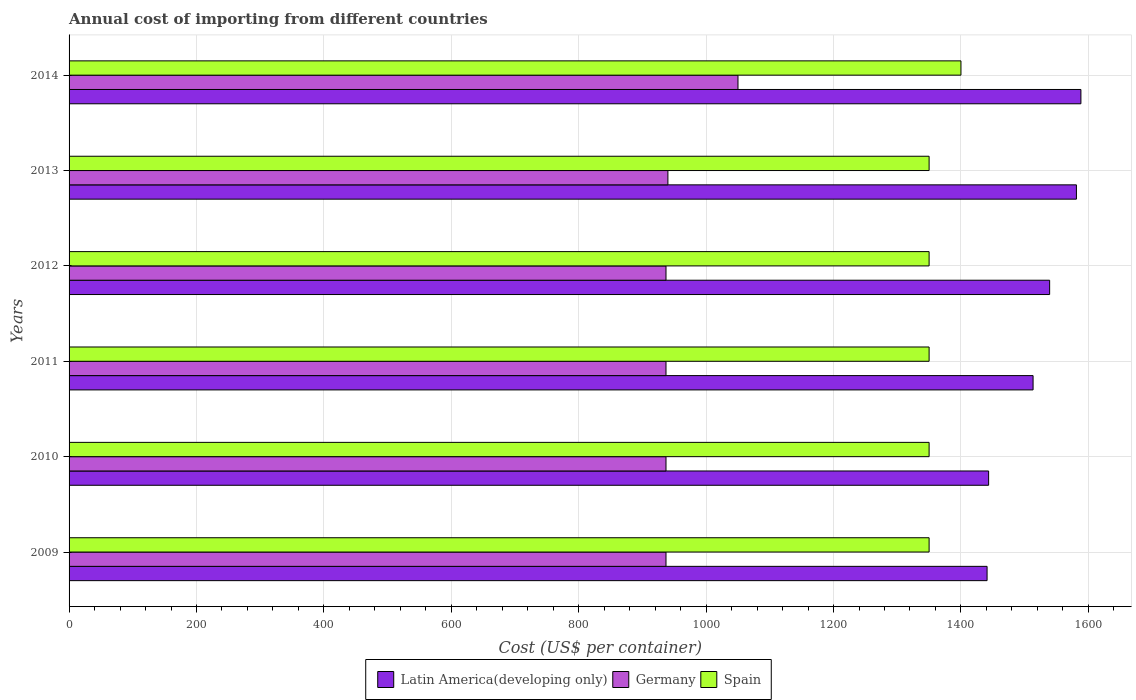Are the number of bars per tick equal to the number of legend labels?
Ensure brevity in your answer.  Yes. How many bars are there on the 5th tick from the top?
Offer a terse response. 3. How many bars are there on the 4th tick from the bottom?
Offer a terse response. 3. In how many cases, is the number of bars for a given year not equal to the number of legend labels?
Provide a short and direct response. 0. What is the total annual cost of importing in Spain in 2014?
Your response must be concise. 1400. Across all years, what is the maximum total annual cost of importing in Germany?
Offer a very short reply. 1050. Across all years, what is the minimum total annual cost of importing in Latin America(developing only)?
Provide a short and direct response. 1441. In which year was the total annual cost of importing in Spain maximum?
Provide a short and direct response. 2014. What is the total total annual cost of importing in Germany in the graph?
Make the answer very short. 5738. What is the difference between the total annual cost of importing in Germany in 2011 and that in 2012?
Provide a short and direct response. 0. What is the difference between the total annual cost of importing in Spain in 2011 and the total annual cost of importing in Latin America(developing only) in 2013?
Offer a terse response. -231.26. What is the average total annual cost of importing in Germany per year?
Give a very brief answer. 956.33. In the year 2012, what is the difference between the total annual cost of importing in Germany and total annual cost of importing in Latin America(developing only)?
Provide a short and direct response. -602.22. In how many years, is the total annual cost of importing in Germany greater than 880 US$?
Make the answer very short. 6. Is the difference between the total annual cost of importing in Germany in 2009 and 2013 greater than the difference between the total annual cost of importing in Latin America(developing only) in 2009 and 2013?
Offer a very short reply. Yes. What is the difference between the highest and the second highest total annual cost of importing in Latin America(developing only)?
Make the answer very short. 7.02. What is the difference between the highest and the lowest total annual cost of importing in Germany?
Provide a short and direct response. 113. Is the sum of the total annual cost of importing in Spain in 2011 and 2013 greater than the maximum total annual cost of importing in Latin America(developing only) across all years?
Give a very brief answer. Yes. What does the 1st bar from the top in 2010 represents?
Provide a succinct answer. Spain. What does the 1st bar from the bottom in 2011 represents?
Offer a very short reply. Latin America(developing only). Is it the case that in every year, the sum of the total annual cost of importing in Spain and total annual cost of importing in Germany is greater than the total annual cost of importing in Latin America(developing only)?
Your answer should be compact. Yes. How many bars are there?
Offer a terse response. 18. How many years are there in the graph?
Keep it short and to the point. 6. How many legend labels are there?
Offer a terse response. 3. How are the legend labels stacked?
Give a very brief answer. Horizontal. What is the title of the graph?
Provide a succinct answer. Annual cost of importing from different countries. What is the label or title of the X-axis?
Your answer should be compact. Cost (US$ per container). What is the label or title of the Y-axis?
Ensure brevity in your answer.  Years. What is the Cost (US$ per container) of Latin America(developing only) in 2009?
Your answer should be compact. 1441. What is the Cost (US$ per container) of Germany in 2009?
Ensure brevity in your answer.  937. What is the Cost (US$ per container) of Spain in 2009?
Offer a very short reply. 1350. What is the Cost (US$ per container) of Latin America(developing only) in 2010?
Offer a terse response. 1443.43. What is the Cost (US$ per container) of Germany in 2010?
Offer a very short reply. 937. What is the Cost (US$ per container) in Spain in 2010?
Ensure brevity in your answer.  1350. What is the Cost (US$ per container) of Latin America(developing only) in 2011?
Give a very brief answer. 1513.22. What is the Cost (US$ per container) of Germany in 2011?
Offer a very short reply. 937. What is the Cost (US$ per container) in Spain in 2011?
Give a very brief answer. 1350. What is the Cost (US$ per container) in Latin America(developing only) in 2012?
Your answer should be compact. 1539.22. What is the Cost (US$ per container) of Germany in 2012?
Your response must be concise. 937. What is the Cost (US$ per container) in Spain in 2012?
Keep it short and to the point. 1350. What is the Cost (US$ per container) in Latin America(developing only) in 2013?
Provide a short and direct response. 1581.26. What is the Cost (US$ per container) of Germany in 2013?
Give a very brief answer. 940. What is the Cost (US$ per container) of Spain in 2013?
Your response must be concise. 1350. What is the Cost (US$ per container) of Latin America(developing only) in 2014?
Your response must be concise. 1588.28. What is the Cost (US$ per container) of Germany in 2014?
Make the answer very short. 1050. What is the Cost (US$ per container) of Spain in 2014?
Your answer should be very brief. 1400. Across all years, what is the maximum Cost (US$ per container) of Latin America(developing only)?
Keep it short and to the point. 1588.28. Across all years, what is the maximum Cost (US$ per container) of Germany?
Provide a succinct answer. 1050. Across all years, what is the maximum Cost (US$ per container) of Spain?
Offer a very short reply. 1400. Across all years, what is the minimum Cost (US$ per container) of Latin America(developing only)?
Your answer should be compact. 1441. Across all years, what is the minimum Cost (US$ per container) of Germany?
Give a very brief answer. 937. Across all years, what is the minimum Cost (US$ per container) of Spain?
Give a very brief answer. 1350. What is the total Cost (US$ per container) in Latin America(developing only) in the graph?
Offer a terse response. 9106.4. What is the total Cost (US$ per container) in Germany in the graph?
Your answer should be compact. 5738. What is the total Cost (US$ per container) in Spain in the graph?
Ensure brevity in your answer.  8150. What is the difference between the Cost (US$ per container) of Latin America(developing only) in 2009 and that in 2010?
Your answer should be compact. -2.43. What is the difference between the Cost (US$ per container) of Latin America(developing only) in 2009 and that in 2011?
Provide a succinct answer. -72.22. What is the difference between the Cost (US$ per container) of Spain in 2009 and that in 2011?
Your response must be concise. 0. What is the difference between the Cost (US$ per container) in Latin America(developing only) in 2009 and that in 2012?
Provide a succinct answer. -98.22. What is the difference between the Cost (US$ per container) of Germany in 2009 and that in 2012?
Offer a terse response. 0. What is the difference between the Cost (US$ per container) of Latin America(developing only) in 2009 and that in 2013?
Make the answer very short. -140.26. What is the difference between the Cost (US$ per container) in Germany in 2009 and that in 2013?
Provide a succinct answer. -3. What is the difference between the Cost (US$ per container) of Spain in 2009 and that in 2013?
Your answer should be very brief. 0. What is the difference between the Cost (US$ per container) in Latin America(developing only) in 2009 and that in 2014?
Make the answer very short. -147.28. What is the difference between the Cost (US$ per container) of Germany in 2009 and that in 2014?
Your response must be concise. -113. What is the difference between the Cost (US$ per container) in Spain in 2009 and that in 2014?
Offer a terse response. -50. What is the difference between the Cost (US$ per container) of Latin America(developing only) in 2010 and that in 2011?
Your answer should be very brief. -69.78. What is the difference between the Cost (US$ per container) in Germany in 2010 and that in 2011?
Your answer should be compact. 0. What is the difference between the Cost (US$ per container) of Spain in 2010 and that in 2011?
Provide a short and direct response. 0. What is the difference between the Cost (US$ per container) of Latin America(developing only) in 2010 and that in 2012?
Provide a succinct answer. -95.78. What is the difference between the Cost (US$ per container) of Germany in 2010 and that in 2012?
Provide a short and direct response. 0. What is the difference between the Cost (US$ per container) of Spain in 2010 and that in 2012?
Offer a very short reply. 0. What is the difference between the Cost (US$ per container) in Latin America(developing only) in 2010 and that in 2013?
Provide a succinct answer. -137.82. What is the difference between the Cost (US$ per container) of Latin America(developing only) in 2010 and that in 2014?
Keep it short and to the point. -144.84. What is the difference between the Cost (US$ per container) in Germany in 2010 and that in 2014?
Make the answer very short. -113. What is the difference between the Cost (US$ per container) of Germany in 2011 and that in 2012?
Give a very brief answer. 0. What is the difference between the Cost (US$ per container) in Spain in 2011 and that in 2012?
Provide a short and direct response. 0. What is the difference between the Cost (US$ per container) of Latin America(developing only) in 2011 and that in 2013?
Ensure brevity in your answer.  -68.04. What is the difference between the Cost (US$ per container) in Spain in 2011 and that in 2013?
Provide a short and direct response. 0. What is the difference between the Cost (US$ per container) in Latin America(developing only) in 2011 and that in 2014?
Provide a succinct answer. -75.06. What is the difference between the Cost (US$ per container) of Germany in 2011 and that in 2014?
Your answer should be compact. -113. What is the difference between the Cost (US$ per container) of Spain in 2011 and that in 2014?
Give a very brief answer. -50. What is the difference between the Cost (US$ per container) of Latin America(developing only) in 2012 and that in 2013?
Ensure brevity in your answer.  -42.04. What is the difference between the Cost (US$ per container) in Germany in 2012 and that in 2013?
Provide a succinct answer. -3. What is the difference between the Cost (US$ per container) of Latin America(developing only) in 2012 and that in 2014?
Provide a succinct answer. -49.06. What is the difference between the Cost (US$ per container) in Germany in 2012 and that in 2014?
Keep it short and to the point. -113. What is the difference between the Cost (US$ per container) of Latin America(developing only) in 2013 and that in 2014?
Make the answer very short. -7.02. What is the difference between the Cost (US$ per container) in Germany in 2013 and that in 2014?
Offer a very short reply. -110. What is the difference between the Cost (US$ per container) in Spain in 2013 and that in 2014?
Offer a terse response. -50. What is the difference between the Cost (US$ per container) of Latin America(developing only) in 2009 and the Cost (US$ per container) of Germany in 2010?
Your response must be concise. 504. What is the difference between the Cost (US$ per container) of Latin America(developing only) in 2009 and the Cost (US$ per container) of Spain in 2010?
Your response must be concise. 91. What is the difference between the Cost (US$ per container) of Germany in 2009 and the Cost (US$ per container) of Spain in 2010?
Give a very brief answer. -413. What is the difference between the Cost (US$ per container) of Latin America(developing only) in 2009 and the Cost (US$ per container) of Germany in 2011?
Your answer should be very brief. 504. What is the difference between the Cost (US$ per container) of Latin America(developing only) in 2009 and the Cost (US$ per container) of Spain in 2011?
Your answer should be compact. 91. What is the difference between the Cost (US$ per container) of Germany in 2009 and the Cost (US$ per container) of Spain in 2011?
Your response must be concise. -413. What is the difference between the Cost (US$ per container) in Latin America(developing only) in 2009 and the Cost (US$ per container) in Germany in 2012?
Offer a terse response. 504. What is the difference between the Cost (US$ per container) in Latin America(developing only) in 2009 and the Cost (US$ per container) in Spain in 2012?
Offer a terse response. 91. What is the difference between the Cost (US$ per container) in Germany in 2009 and the Cost (US$ per container) in Spain in 2012?
Your answer should be very brief. -413. What is the difference between the Cost (US$ per container) in Latin America(developing only) in 2009 and the Cost (US$ per container) in Germany in 2013?
Your answer should be very brief. 501. What is the difference between the Cost (US$ per container) of Latin America(developing only) in 2009 and the Cost (US$ per container) of Spain in 2013?
Provide a short and direct response. 91. What is the difference between the Cost (US$ per container) of Germany in 2009 and the Cost (US$ per container) of Spain in 2013?
Ensure brevity in your answer.  -413. What is the difference between the Cost (US$ per container) of Latin America(developing only) in 2009 and the Cost (US$ per container) of Germany in 2014?
Provide a short and direct response. 391. What is the difference between the Cost (US$ per container) of Latin America(developing only) in 2009 and the Cost (US$ per container) of Spain in 2014?
Give a very brief answer. 41. What is the difference between the Cost (US$ per container) in Germany in 2009 and the Cost (US$ per container) in Spain in 2014?
Provide a short and direct response. -463. What is the difference between the Cost (US$ per container) in Latin America(developing only) in 2010 and the Cost (US$ per container) in Germany in 2011?
Offer a very short reply. 506.43. What is the difference between the Cost (US$ per container) of Latin America(developing only) in 2010 and the Cost (US$ per container) of Spain in 2011?
Your response must be concise. 93.43. What is the difference between the Cost (US$ per container) in Germany in 2010 and the Cost (US$ per container) in Spain in 2011?
Offer a very short reply. -413. What is the difference between the Cost (US$ per container) of Latin America(developing only) in 2010 and the Cost (US$ per container) of Germany in 2012?
Your answer should be compact. 506.43. What is the difference between the Cost (US$ per container) of Latin America(developing only) in 2010 and the Cost (US$ per container) of Spain in 2012?
Provide a short and direct response. 93.43. What is the difference between the Cost (US$ per container) of Germany in 2010 and the Cost (US$ per container) of Spain in 2012?
Ensure brevity in your answer.  -413. What is the difference between the Cost (US$ per container) of Latin America(developing only) in 2010 and the Cost (US$ per container) of Germany in 2013?
Provide a short and direct response. 503.43. What is the difference between the Cost (US$ per container) in Latin America(developing only) in 2010 and the Cost (US$ per container) in Spain in 2013?
Make the answer very short. 93.43. What is the difference between the Cost (US$ per container) of Germany in 2010 and the Cost (US$ per container) of Spain in 2013?
Offer a very short reply. -413. What is the difference between the Cost (US$ per container) of Latin America(developing only) in 2010 and the Cost (US$ per container) of Germany in 2014?
Give a very brief answer. 393.43. What is the difference between the Cost (US$ per container) of Latin America(developing only) in 2010 and the Cost (US$ per container) of Spain in 2014?
Your answer should be very brief. 43.43. What is the difference between the Cost (US$ per container) in Germany in 2010 and the Cost (US$ per container) in Spain in 2014?
Ensure brevity in your answer.  -463. What is the difference between the Cost (US$ per container) in Latin America(developing only) in 2011 and the Cost (US$ per container) in Germany in 2012?
Provide a succinct answer. 576.22. What is the difference between the Cost (US$ per container) in Latin America(developing only) in 2011 and the Cost (US$ per container) in Spain in 2012?
Your answer should be compact. 163.22. What is the difference between the Cost (US$ per container) of Germany in 2011 and the Cost (US$ per container) of Spain in 2012?
Provide a succinct answer. -413. What is the difference between the Cost (US$ per container) in Latin America(developing only) in 2011 and the Cost (US$ per container) in Germany in 2013?
Make the answer very short. 573.22. What is the difference between the Cost (US$ per container) of Latin America(developing only) in 2011 and the Cost (US$ per container) of Spain in 2013?
Keep it short and to the point. 163.22. What is the difference between the Cost (US$ per container) in Germany in 2011 and the Cost (US$ per container) in Spain in 2013?
Provide a short and direct response. -413. What is the difference between the Cost (US$ per container) of Latin America(developing only) in 2011 and the Cost (US$ per container) of Germany in 2014?
Offer a terse response. 463.22. What is the difference between the Cost (US$ per container) in Latin America(developing only) in 2011 and the Cost (US$ per container) in Spain in 2014?
Provide a succinct answer. 113.22. What is the difference between the Cost (US$ per container) in Germany in 2011 and the Cost (US$ per container) in Spain in 2014?
Your answer should be compact. -463. What is the difference between the Cost (US$ per container) of Latin America(developing only) in 2012 and the Cost (US$ per container) of Germany in 2013?
Make the answer very short. 599.22. What is the difference between the Cost (US$ per container) in Latin America(developing only) in 2012 and the Cost (US$ per container) in Spain in 2013?
Keep it short and to the point. 189.22. What is the difference between the Cost (US$ per container) in Germany in 2012 and the Cost (US$ per container) in Spain in 2013?
Your answer should be compact. -413. What is the difference between the Cost (US$ per container) in Latin America(developing only) in 2012 and the Cost (US$ per container) in Germany in 2014?
Your response must be concise. 489.22. What is the difference between the Cost (US$ per container) of Latin America(developing only) in 2012 and the Cost (US$ per container) of Spain in 2014?
Provide a short and direct response. 139.22. What is the difference between the Cost (US$ per container) of Germany in 2012 and the Cost (US$ per container) of Spain in 2014?
Provide a short and direct response. -463. What is the difference between the Cost (US$ per container) in Latin America(developing only) in 2013 and the Cost (US$ per container) in Germany in 2014?
Give a very brief answer. 531.26. What is the difference between the Cost (US$ per container) in Latin America(developing only) in 2013 and the Cost (US$ per container) in Spain in 2014?
Ensure brevity in your answer.  181.26. What is the difference between the Cost (US$ per container) in Germany in 2013 and the Cost (US$ per container) in Spain in 2014?
Offer a terse response. -460. What is the average Cost (US$ per container) of Latin America(developing only) per year?
Offer a terse response. 1517.73. What is the average Cost (US$ per container) of Germany per year?
Your response must be concise. 956.33. What is the average Cost (US$ per container) of Spain per year?
Provide a short and direct response. 1358.33. In the year 2009, what is the difference between the Cost (US$ per container) in Latin America(developing only) and Cost (US$ per container) in Germany?
Offer a terse response. 504. In the year 2009, what is the difference between the Cost (US$ per container) in Latin America(developing only) and Cost (US$ per container) in Spain?
Keep it short and to the point. 91. In the year 2009, what is the difference between the Cost (US$ per container) of Germany and Cost (US$ per container) of Spain?
Give a very brief answer. -413. In the year 2010, what is the difference between the Cost (US$ per container) of Latin America(developing only) and Cost (US$ per container) of Germany?
Provide a succinct answer. 506.43. In the year 2010, what is the difference between the Cost (US$ per container) of Latin America(developing only) and Cost (US$ per container) of Spain?
Ensure brevity in your answer.  93.43. In the year 2010, what is the difference between the Cost (US$ per container) in Germany and Cost (US$ per container) in Spain?
Make the answer very short. -413. In the year 2011, what is the difference between the Cost (US$ per container) of Latin America(developing only) and Cost (US$ per container) of Germany?
Make the answer very short. 576.22. In the year 2011, what is the difference between the Cost (US$ per container) of Latin America(developing only) and Cost (US$ per container) of Spain?
Your response must be concise. 163.22. In the year 2011, what is the difference between the Cost (US$ per container) of Germany and Cost (US$ per container) of Spain?
Keep it short and to the point. -413. In the year 2012, what is the difference between the Cost (US$ per container) in Latin America(developing only) and Cost (US$ per container) in Germany?
Offer a terse response. 602.22. In the year 2012, what is the difference between the Cost (US$ per container) in Latin America(developing only) and Cost (US$ per container) in Spain?
Ensure brevity in your answer.  189.22. In the year 2012, what is the difference between the Cost (US$ per container) in Germany and Cost (US$ per container) in Spain?
Give a very brief answer. -413. In the year 2013, what is the difference between the Cost (US$ per container) in Latin America(developing only) and Cost (US$ per container) in Germany?
Keep it short and to the point. 641.26. In the year 2013, what is the difference between the Cost (US$ per container) in Latin America(developing only) and Cost (US$ per container) in Spain?
Offer a terse response. 231.26. In the year 2013, what is the difference between the Cost (US$ per container) of Germany and Cost (US$ per container) of Spain?
Your response must be concise. -410. In the year 2014, what is the difference between the Cost (US$ per container) of Latin America(developing only) and Cost (US$ per container) of Germany?
Provide a short and direct response. 538.28. In the year 2014, what is the difference between the Cost (US$ per container) of Latin America(developing only) and Cost (US$ per container) of Spain?
Keep it short and to the point. 188.28. In the year 2014, what is the difference between the Cost (US$ per container) of Germany and Cost (US$ per container) of Spain?
Offer a very short reply. -350. What is the ratio of the Cost (US$ per container) of Latin America(developing only) in 2009 to that in 2010?
Provide a short and direct response. 1. What is the ratio of the Cost (US$ per container) of Germany in 2009 to that in 2010?
Provide a short and direct response. 1. What is the ratio of the Cost (US$ per container) of Latin America(developing only) in 2009 to that in 2011?
Provide a succinct answer. 0.95. What is the ratio of the Cost (US$ per container) of Germany in 2009 to that in 2011?
Keep it short and to the point. 1. What is the ratio of the Cost (US$ per container) in Spain in 2009 to that in 2011?
Make the answer very short. 1. What is the ratio of the Cost (US$ per container) in Latin America(developing only) in 2009 to that in 2012?
Your response must be concise. 0.94. What is the ratio of the Cost (US$ per container) of Germany in 2009 to that in 2012?
Provide a succinct answer. 1. What is the ratio of the Cost (US$ per container) in Latin America(developing only) in 2009 to that in 2013?
Provide a succinct answer. 0.91. What is the ratio of the Cost (US$ per container) of Germany in 2009 to that in 2013?
Make the answer very short. 1. What is the ratio of the Cost (US$ per container) of Latin America(developing only) in 2009 to that in 2014?
Give a very brief answer. 0.91. What is the ratio of the Cost (US$ per container) in Germany in 2009 to that in 2014?
Give a very brief answer. 0.89. What is the ratio of the Cost (US$ per container) in Latin America(developing only) in 2010 to that in 2011?
Provide a short and direct response. 0.95. What is the ratio of the Cost (US$ per container) of Germany in 2010 to that in 2011?
Your response must be concise. 1. What is the ratio of the Cost (US$ per container) of Latin America(developing only) in 2010 to that in 2012?
Keep it short and to the point. 0.94. What is the ratio of the Cost (US$ per container) in Latin America(developing only) in 2010 to that in 2013?
Keep it short and to the point. 0.91. What is the ratio of the Cost (US$ per container) of Spain in 2010 to that in 2013?
Your response must be concise. 1. What is the ratio of the Cost (US$ per container) of Latin America(developing only) in 2010 to that in 2014?
Offer a very short reply. 0.91. What is the ratio of the Cost (US$ per container) of Germany in 2010 to that in 2014?
Provide a succinct answer. 0.89. What is the ratio of the Cost (US$ per container) in Spain in 2010 to that in 2014?
Your response must be concise. 0.96. What is the ratio of the Cost (US$ per container) in Latin America(developing only) in 2011 to that in 2012?
Your answer should be compact. 0.98. What is the ratio of the Cost (US$ per container) in Spain in 2011 to that in 2013?
Offer a terse response. 1. What is the ratio of the Cost (US$ per container) in Latin America(developing only) in 2011 to that in 2014?
Make the answer very short. 0.95. What is the ratio of the Cost (US$ per container) of Germany in 2011 to that in 2014?
Give a very brief answer. 0.89. What is the ratio of the Cost (US$ per container) in Spain in 2011 to that in 2014?
Offer a very short reply. 0.96. What is the ratio of the Cost (US$ per container) of Latin America(developing only) in 2012 to that in 2013?
Make the answer very short. 0.97. What is the ratio of the Cost (US$ per container) in Germany in 2012 to that in 2013?
Provide a short and direct response. 1. What is the ratio of the Cost (US$ per container) of Spain in 2012 to that in 2013?
Your answer should be compact. 1. What is the ratio of the Cost (US$ per container) in Latin America(developing only) in 2012 to that in 2014?
Give a very brief answer. 0.97. What is the ratio of the Cost (US$ per container) of Germany in 2012 to that in 2014?
Offer a very short reply. 0.89. What is the ratio of the Cost (US$ per container) of Germany in 2013 to that in 2014?
Your answer should be compact. 0.9. What is the difference between the highest and the second highest Cost (US$ per container) of Latin America(developing only)?
Offer a very short reply. 7.02. What is the difference between the highest and the second highest Cost (US$ per container) in Germany?
Provide a succinct answer. 110. What is the difference between the highest and the lowest Cost (US$ per container) of Latin America(developing only)?
Provide a short and direct response. 147.28. What is the difference between the highest and the lowest Cost (US$ per container) in Germany?
Your answer should be very brief. 113. What is the difference between the highest and the lowest Cost (US$ per container) of Spain?
Provide a short and direct response. 50. 